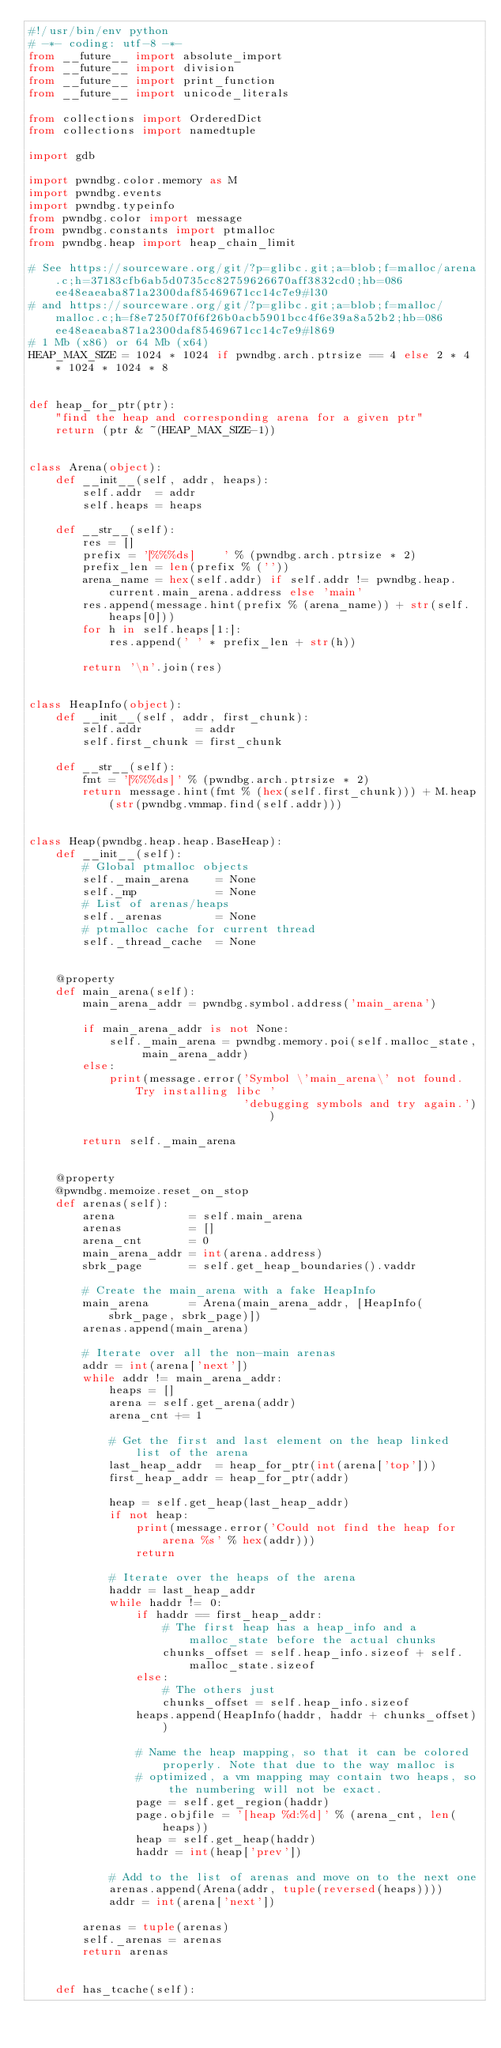<code> <loc_0><loc_0><loc_500><loc_500><_Python_>#!/usr/bin/env python
# -*- coding: utf-8 -*-
from __future__ import absolute_import
from __future__ import division
from __future__ import print_function
from __future__ import unicode_literals

from collections import OrderedDict
from collections import namedtuple

import gdb

import pwndbg.color.memory as M
import pwndbg.events
import pwndbg.typeinfo
from pwndbg.color import message
from pwndbg.constants import ptmalloc
from pwndbg.heap import heap_chain_limit

# See https://sourceware.org/git/?p=glibc.git;a=blob;f=malloc/arena.c;h=37183cfb6ab5d0735cc82759626670aff3832cd0;hb=086ee48eaeaba871a2300daf85469671cc14c7e9#l30
# and https://sourceware.org/git/?p=glibc.git;a=blob;f=malloc/malloc.c;h=f8e7250f70f6f26b0acb5901bcc4f6e39a8a52b2;hb=086ee48eaeaba871a2300daf85469671cc14c7e9#l869
# 1 Mb (x86) or 64 Mb (x64)
HEAP_MAX_SIZE = 1024 * 1024 if pwndbg.arch.ptrsize == 4 else 2 * 4 * 1024 * 1024 * 8


def heap_for_ptr(ptr):
    "find the heap and corresponding arena for a given ptr"
    return (ptr & ~(HEAP_MAX_SIZE-1))


class Arena(object):
    def __init__(self, addr, heaps):
        self.addr  = addr
        self.heaps = heaps

    def __str__(self):
        res = []
        prefix = '[%%%ds]    ' % (pwndbg.arch.ptrsize * 2)
        prefix_len = len(prefix % (''))
        arena_name = hex(self.addr) if self.addr != pwndbg.heap.current.main_arena.address else 'main'
        res.append(message.hint(prefix % (arena_name)) + str(self.heaps[0]))
        for h in self.heaps[1:]:
            res.append(' ' * prefix_len + str(h))

        return '\n'.join(res)


class HeapInfo(object):
    def __init__(self, addr, first_chunk):
        self.addr        = addr
        self.first_chunk = first_chunk

    def __str__(self):
        fmt = '[%%%ds]' % (pwndbg.arch.ptrsize * 2)
        return message.hint(fmt % (hex(self.first_chunk))) + M.heap(str(pwndbg.vmmap.find(self.addr)))


class Heap(pwndbg.heap.heap.BaseHeap):
    def __init__(self):
        # Global ptmalloc objects
        self._main_arena    = None
        self._mp            = None
        # List of arenas/heaps
        self._arenas        = None
        # ptmalloc cache for current thread
        self._thread_cache  = None


    @property
    def main_arena(self):
        main_arena_addr = pwndbg.symbol.address('main_arena')

        if main_arena_addr is not None:
            self._main_arena = pwndbg.memory.poi(self.malloc_state, main_arena_addr)
        else:
            print(message.error('Symbol \'main_arena\' not found. Try installing libc '
                                'debugging symbols and try again.'))

        return self._main_arena


    @property
    @pwndbg.memoize.reset_on_stop
    def arenas(self):
        arena           = self.main_arena
        arenas          = []
        arena_cnt       = 0
        main_arena_addr = int(arena.address)
        sbrk_page       = self.get_heap_boundaries().vaddr

        # Create the main_arena with a fake HeapInfo
        main_arena      = Arena(main_arena_addr, [HeapInfo(sbrk_page, sbrk_page)])
        arenas.append(main_arena)

        # Iterate over all the non-main arenas
        addr = int(arena['next'])
        while addr != main_arena_addr:
            heaps = []
            arena = self.get_arena(addr)
            arena_cnt += 1

            # Get the first and last element on the heap linked list of the arena
            last_heap_addr  = heap_for_ptr(int(arena['top']))
            first_heap_addr = heap_for_ptr(addr)

            heap = self.get_heap(last_heap_addr)
            if not heap:
                print(message.error('Could not find the heap for arena %s' % hex(addr)))
                return

            # Iterate over the heaps of the arena
            haddr = last_heap_addr
            while haddr != 0:
                if haddr == first_heap_addr:
                    # The first heap has a heap_info and a malloc_state before the actual chunks
                    chunks_offset = self.heap_info.sizeof + self.malloc_state.sizeof
                else:
                    # The others just
                    chunks_offset = self.heap_info.sizeof
                heaps.append(HeapInfo(haddr, haddr + chunks_offset))

                # Name the heap mapping, so that it can be colored properly. Note that due to the way malloc is
                # optimized, a vm mapping may contain two heaps, so the numbering will not be exact.
                page = self.get_region(haddr)
                page.objfile = '[heap %d:%d]' % (arena_cnt, len(heaps))
                heap = self.get_heap(haddr)
                haddr = int(heap['prev'])

            # Add to the list of arenas and move on to the next one
            arenas.append(Arena(addr, tuple(reversed(heaps))))
            addr = int(arena['next'])

        arenas = tuple(arenas)
        self._arenas = arenas
        return arenas


    def has_tcache(self):</code> 